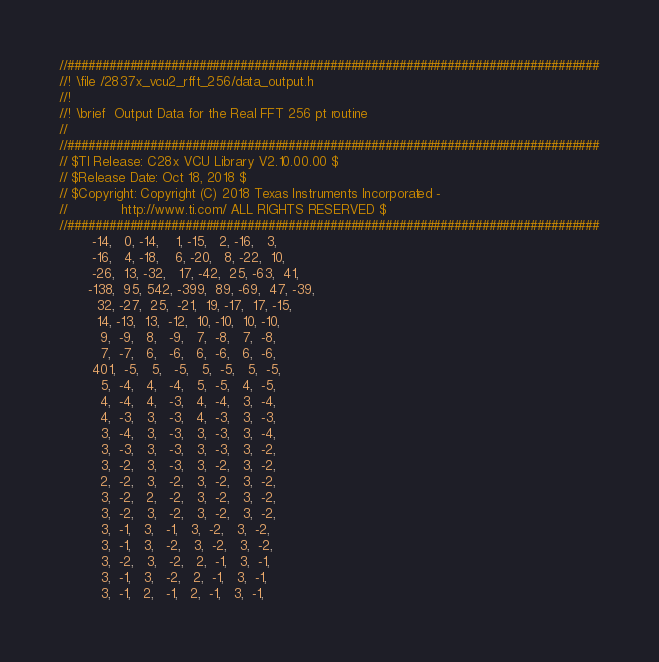Convert code to text. <code><loc_0><loc_0><loc_500><loc_500><_C_>//#############################################################################
//! \file /2837x_vcu2_rfft_256/data_output.h
//!
//! \brief  Output Data for the Real FFT 256 pt routine
//
//#############################################################################
// $TI Release: C28x VCU Library V2.10.00.00 $
// $Release Date: Oct 18, 2018 $
// $Copyright: Copyright (C) 2018 Texas Instruments Incorporated -
//             http://www.ti.com/ ALL RIGHTS RESERVED $
//#############################################################################
	    -14,   0, -14,    1, -15,   2, -16,   3,
	    -16,   4, -18,    6, -20,   8, -22,  10,
	    -26,  13, -32,   17, -42,  25, -63,  41,
	   -138,  95, 542, -399,  89, -69,  47, -39,
	     32, -27,  25,  -21,  19, -17,  17, -15,
	     14, -13,  13,  -12,  10, -10,  10, -10,
	      9,  -9,   8,   -9,   7,  -8,   7,  -8,
	      7,  -7,   6,   -6,   6,  -6,   6,  -6,
	    401,  -5,   5,   -5,   5,  -5,   5,  -5,
	      5,  -4,   4,   -4,   5,  -5,   4,  -5,
	      4,  -4,   4,   -3,   4,  -4,   3,  -4,
	      4,  -3,   3,   -3,   4,  -3,   3,  -3,
	      3,  -4,   3,   -3,   3,  -3,   3,  -4,
	      3,  -3,   3,   -3,   3,  -3,   3,  -2,
	      3,  -2,   3,   -3,   3,  -2,   3,  -2,
	      2,  -2,   3,   -2,   3,  -2,   3,  -2,
	      3,  -2,   2,   -2,   3,  -2,   3,  -2,
	      3,  -2,   3,   -2,   3,  -2,   3,  -2,
	      3,  -1,   3,   -1,   3,  -2,   3,  -2,
	      3,  -1,   3,   -2,   3,  -2,   3,  -2,
	      3,  -2,   3,   -2,   2,  -1,   3,  -1,
	      3,  -1,   3,   -2,   2,  -1,   3,  -1,
	      3,  -1,   2,   -1,   2,  -1,   3,  -1,</code> 